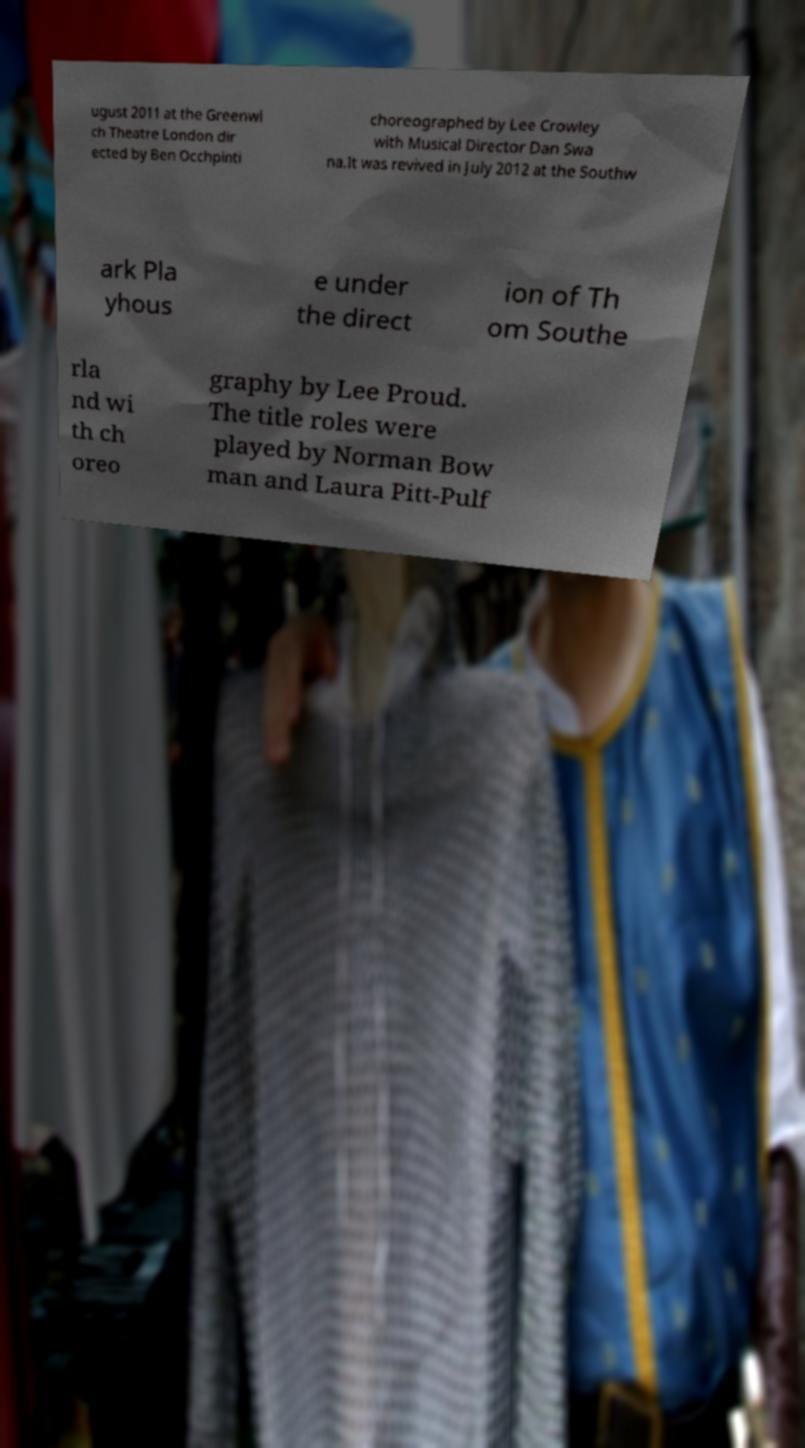For documentation purposes, I need the text within this image transcribed. Could you provide that? ugust 2011 at the Greenwi ch Theatre London dir ected by Ben Occhpinti choreographed by Lee Crowley with Musical Director Dan Swa na.It was revived in July 2012 at the Southw ark Pla yhous e under the direct ion of Th om Southe rla nd wi th ch oreo graphy by Lee Proud. The title roles were played by Norman Bow man and Laura Pitt-Pulf 